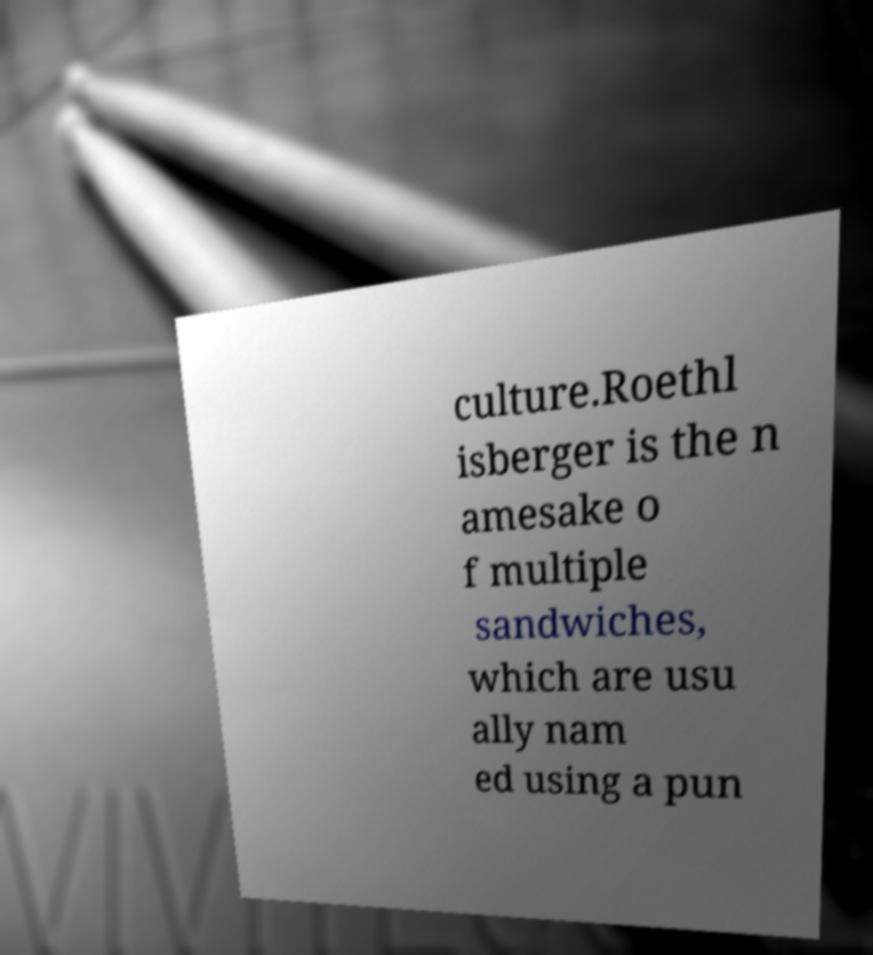For documentation purposes, I need the text within this image transcribed. Could you provide that? culture.Roethl isberger is the n amesake o f multiple sandwiches, which are usu ally nam ed using a pun 